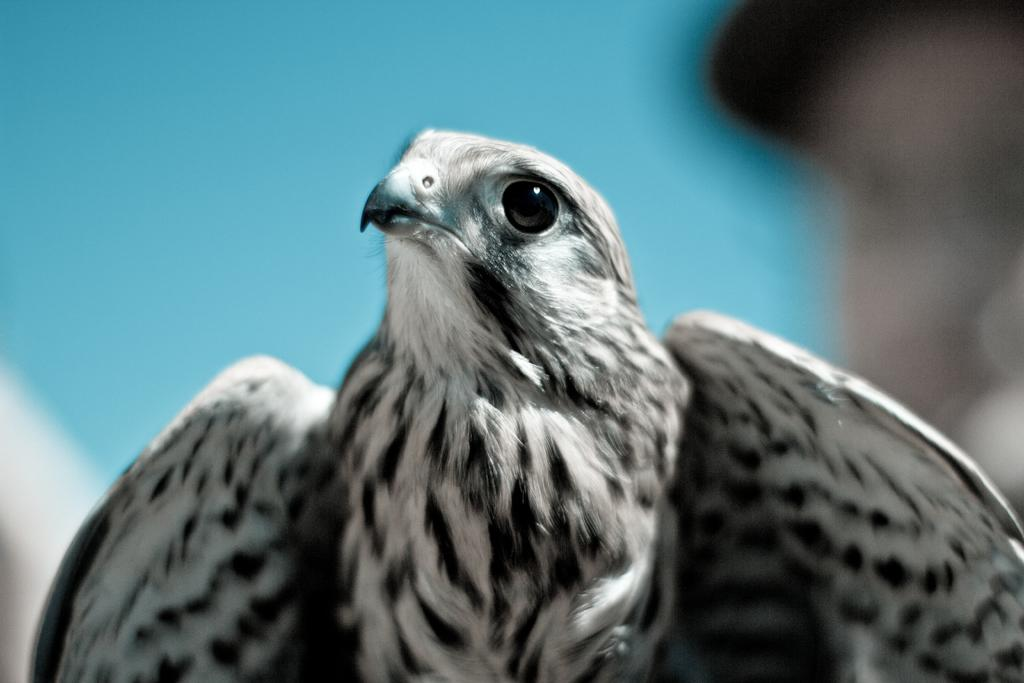What type of animal is present in the image? There is a bird in the image. Can you describe the background of the image? The background of the image is blurred. What is the name of the daughter of the bird in the image? There is no mention of a daughter or any offspring of the bird in the image or the provided facts. Can you tell me if there is a receipt visible in the image? There is no reference to a receipt in the image or the provided facts. 